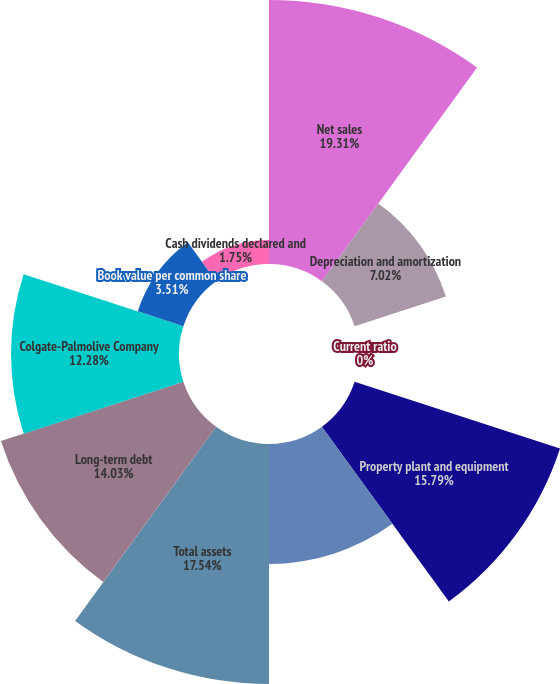Convert chart. <chart><loc_0><loc_0><loc_500><loc_500><pie_chart><fcel>Net sales<fcel>Depreciation and amortization<fcel>Current ratio<fcel>Property plant and equipment<fcel>Capital expenditures<fcel>Total assets<fcel>Long-term debt<fcel>Colgate-Palmolive Company<fcel>Book value per common share<fcel>Cash dividends declared and<nl><fcel>19.3%<fcel>7.02%<fcel>0.0%<fcel>15.79%<fcel>8.77%<fcel>17.54%<fcel>14.03%<fcel>12.28%<fcel>3.51%<fcel>1.75%<nl></chart> 